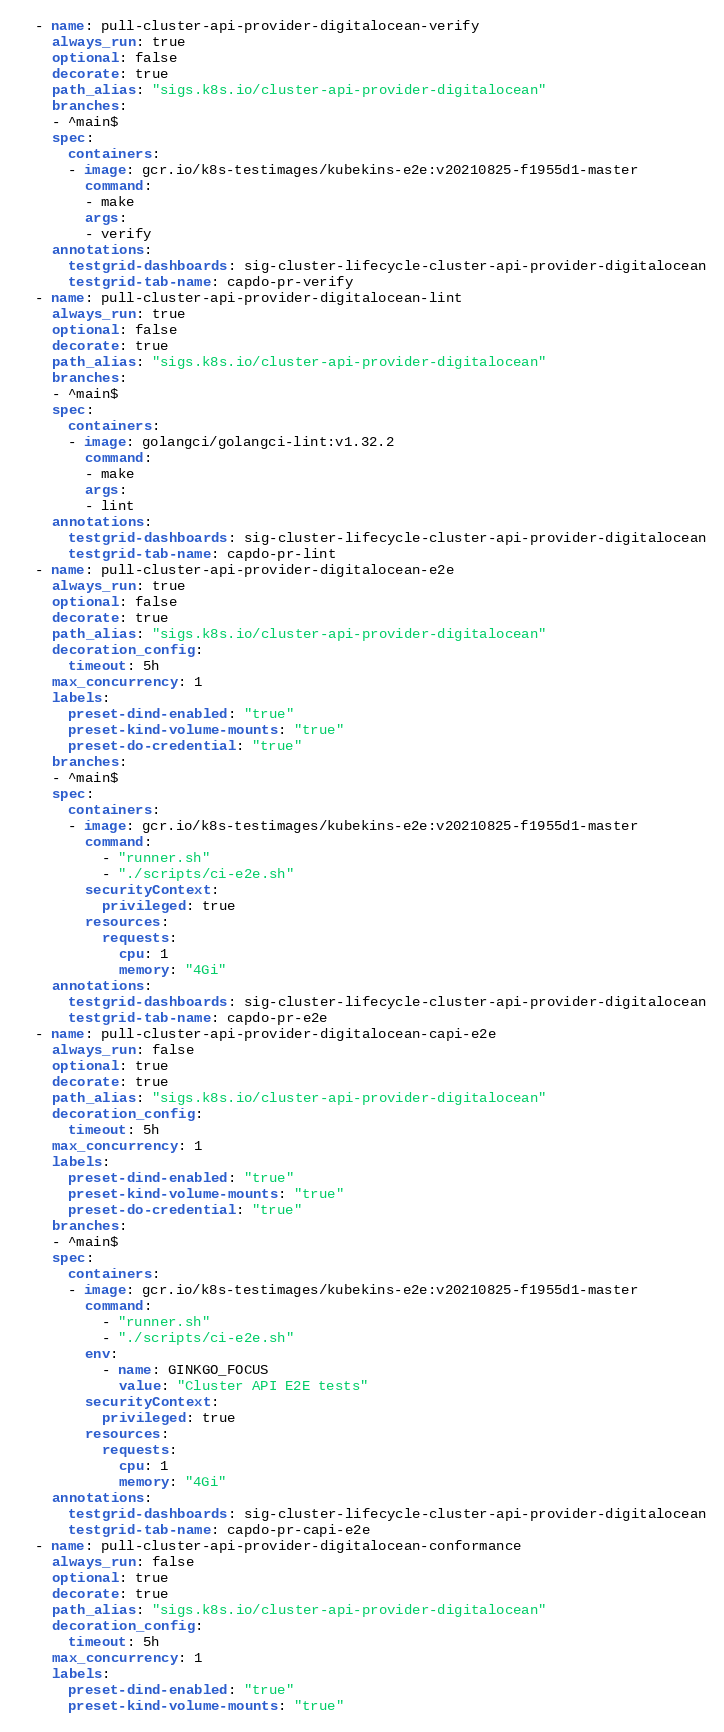<code> <loc_0><loc_0><loc_500><loc_500><_YAML_>  - name: pull-cluster-api-provider-digitalocean-verify
    always_run: true
    optional: false
    decorate: true
    path_alias: "sigs.k8s.io/cluster-api-provider-digitalocean"
    branches:
    - ^main$
    spec:
      containers:
      - image: gcr.io/k8s-testimages/kubekins-e2e:v20210825-f1955d1-master
        command:
        - make
        args:
        - verify
    annotations:
      testgrid-dashboards: sig-cluster-lifecycle-cluster-api-provider-digitalocean
      testgrid-tab-name: capdo-pr-verify
  - name: pull-cluster-api-provider-digitalocean-lint
    always_run: true
    optional: false
    decorate: true
    path_alias: "sigs.k8s.io/cluster-api-provider-digitalocean"
    branches:
    - ^main$
    spec:
      containers:
      - image: golangci/golangci-lint:v1.32.2
        command:
        - make
        args:
        - lint
    annotations:
      testgrid-dashboards: sig-cluster-lifecycle-cluster-api-provider-digitalocean
      testgrid-tab-name: capdo-pr-lint
  - name: pull-cluster-api-provider-digitalocean-e2e
    always_run: true
    optional: false
    decorate: true
    path_alias: "sigs.k8s.io/cluster-api-provider-digitalocean"
    decoration_config:
      timeout: 5h
    max_concurrency: 1
    labels:
      preset-dind-enabled: "true"
      preset-kind-volume-mounts: "true"
      preset-do-credential: "true"
    branches:
    - ^main$
    spec:
      containers:
      - image: gcr.io/k8s-testimages/kubekins-e2e:v20210825-f1955d1-master
        command:
          - "runner.sh"
          - "./scripts/ci-e2e.sh"
        securityContext:
          privileged: true
        resources:
          requests:
            cpu: 1
            memory: "4Gi"
    annotations:
      testgrid-dashboards: sig-cluster-lifecycle-cluster-api-provider-digitalocean
      testgrid-tab-name: capdo-pr-e2e
  - name: pull-cluster-api-provider-digitalocean-capi-e2e
    always_run: false
    optional: true
    decorate: true
    path_alias: "sigs.k8s.io/cluster-api-provider-digitalocean"
    decoration_config:
      timeout: 5h
    max_concurrency: 1
    labels:
      preset-dind-enabled: "true"
      preset-kind-volume-mounts: "true"
      preset-do-credential: "true"
    branches:
    - ^main$
    spec:
      containers:
      - image: gcr.io/k8s-testimages/kubekins-e2e:v20210825-f1955d1-master
        command:
          - "runner.sh"
          - "./scripts/ci-e2e.sh"
        env:
          - name: GINKGO_FOCUS
            value: "Cluster API E2E tests"
        securityContext:
          privileged: true
        resources:
          requests:
            cpu: 1
            memory: "4Gi"
    annotations:
      testgrid-dashboards: sig-cluster-lifecycle-cluster-api-provider-digitalocean
      testgrid-tab-name: capdo-pr-capi-e2e
  - name: pull-cluster-api-provider-digitalocean-conformance
    always_run: false
    optional: true
    decorate: true
    path_alias: "sigs.k8s.io/cluster-api-provider-digitalocean"
    decoration_config:
      timeout: 5h
    max_concurrency: 1
    labels:
      preset-dind-enabled: "true"
      preset-kind-volume-mounts: "true"</code> 